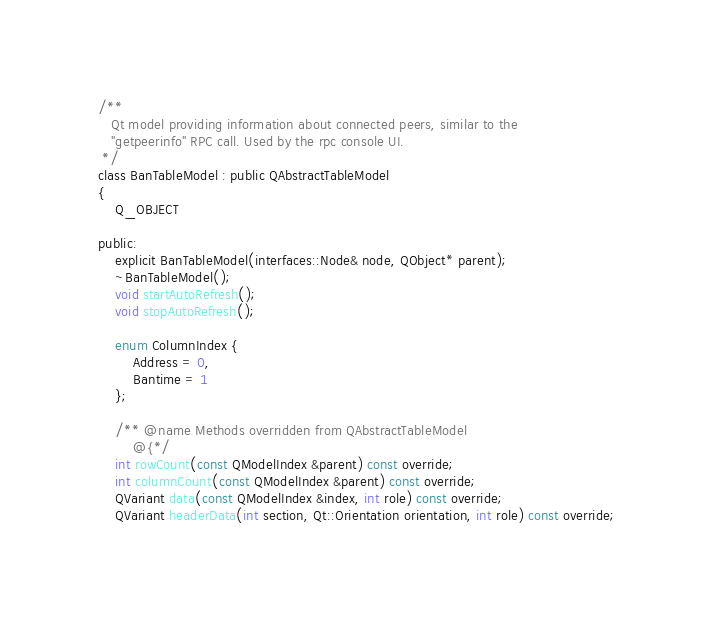<code> <loc_0><loc_0><loc_500><loc_500><_C_>/**
   Qt model providing information about connected peers, similar to the
   "getpeerinfo" RPC call. Used by the rpc console UI.
 */
class BanTableModel : public QAbstractTableModel
{
    Q_OBJECT

public:
    explicit BanTableModel(interfaces::Node& node, QObject* parent);
    ~BanTableModel();
    void startAutoRefresh();
    void stopAutoRefresh();

    enum ColumnIndex {
        Address = 0,
        Bantime = 1
    };

    /** @name Methods overridden from QAbstractTableModel
        @{*/
    int rowCount(const QModelIndex &parent) const override;
    int columnCount(const QModelIndex &parent) const override;
    QVariant data(const QModelIndex &index, int role) const override;
    QVariant headerData(int section, Qt::Orientation orientation, int role) const override;</code> 